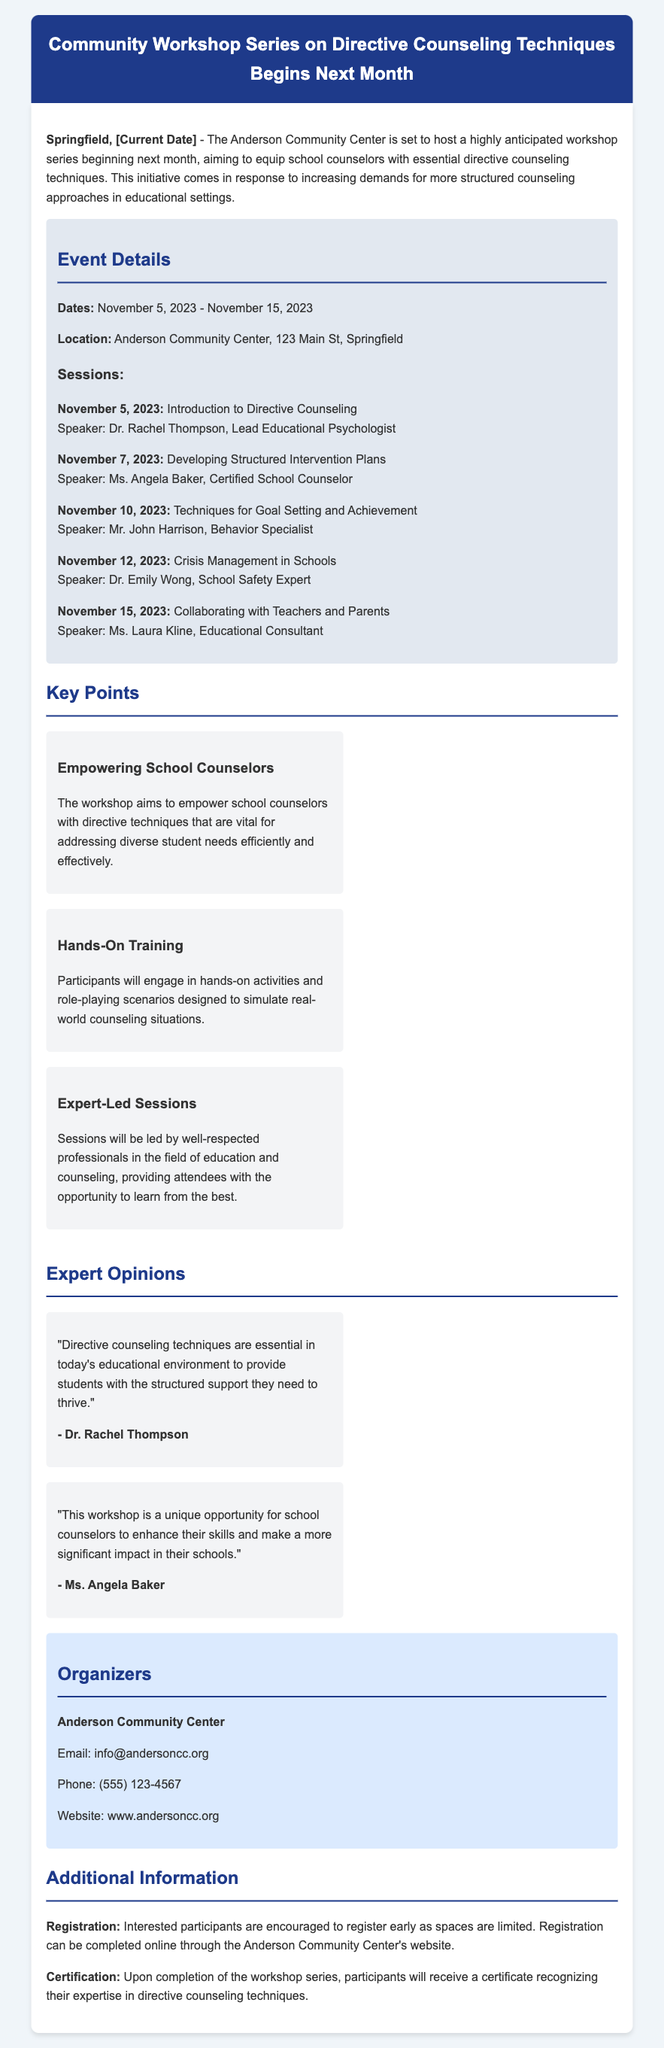What is the start date of the workshop series? The start date is explicitly mentioned in the event details section of the document.
Answer: November 5, 2023 Who is the speaker for the session on Crisis Management in Schools? The speaker's name is provided in the session details for November 12, 2023.
Answer: Dr. Emily Wong How many sessions are scheduled in the workshop series? The document lists five specific sessions under the event details section.
Answer: Five What is the location of the workshop? The exact location is provided in the event details section.
Answer: Anderson Community Center, 123 Main St, Springfield What type of training will participants engage in? This information can be found in the key points section, describing the nature of the activities involved.
Answer: Hands-On Training What will participants receive upon completion of the workshop series? The document mentions certification in the additional information section.
Answer: A certificate How can interested participants register for the workshop? The registration process is outlined in the additional information section of the document.
Answer: Online through the website Who is hosting the workshop series? The organizer is explicitly noted in the organizers section of the document.
Answer: Anderson Community Center 